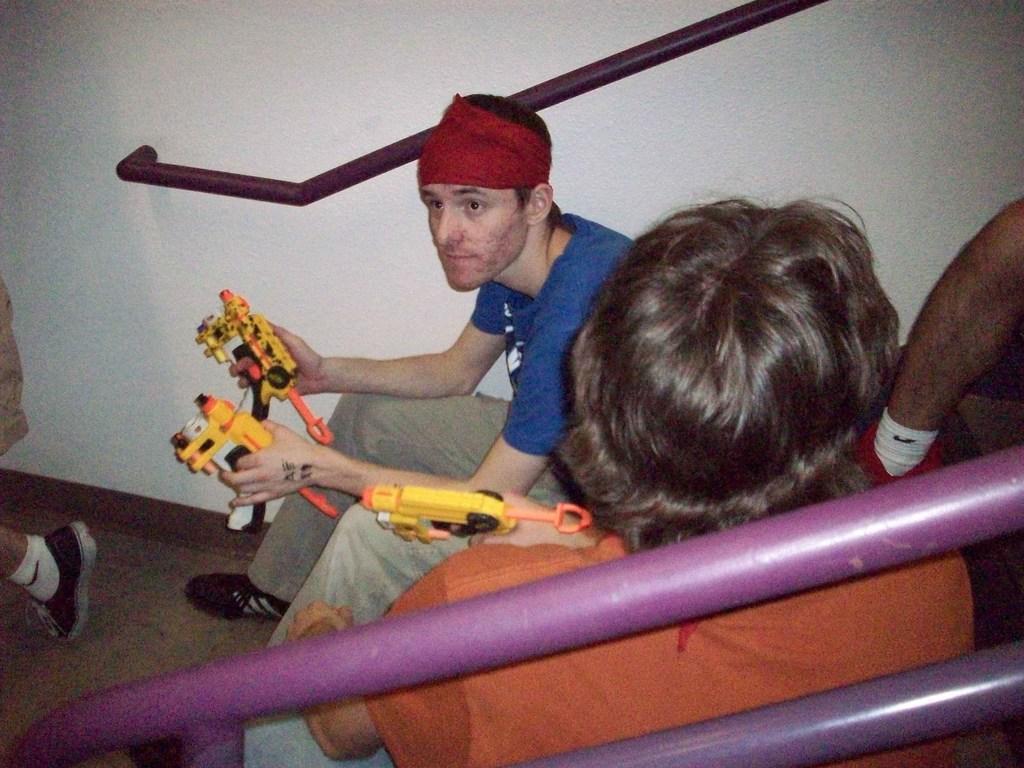Could you give a brief overview of what you see in this image? In the picture we can see two persons sitting and holding toys in their hands and in the background of the picture there is a wall. 